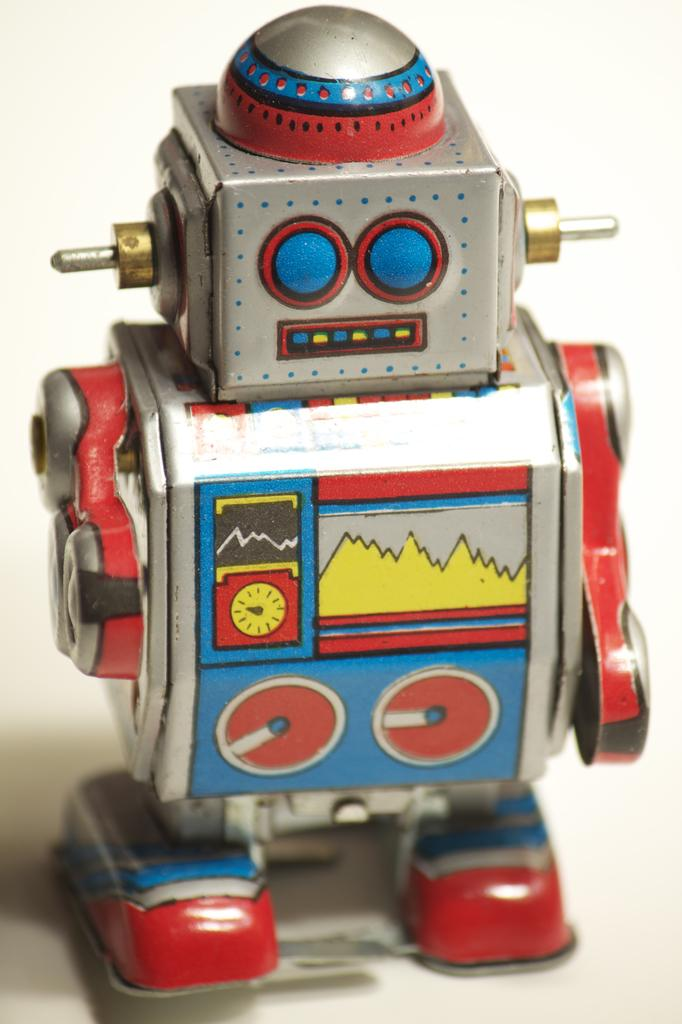What is the main subject of the image? The main subject of the image is a robot toy. Where is the robot toy located in the image? The robot toy is in the middle of the image. What type of sky is visible in the image? There is no sky visible in the image; it only features a robot toy. How many geese are present in the image? There are no geese present in the image; it only features a robot toy. 